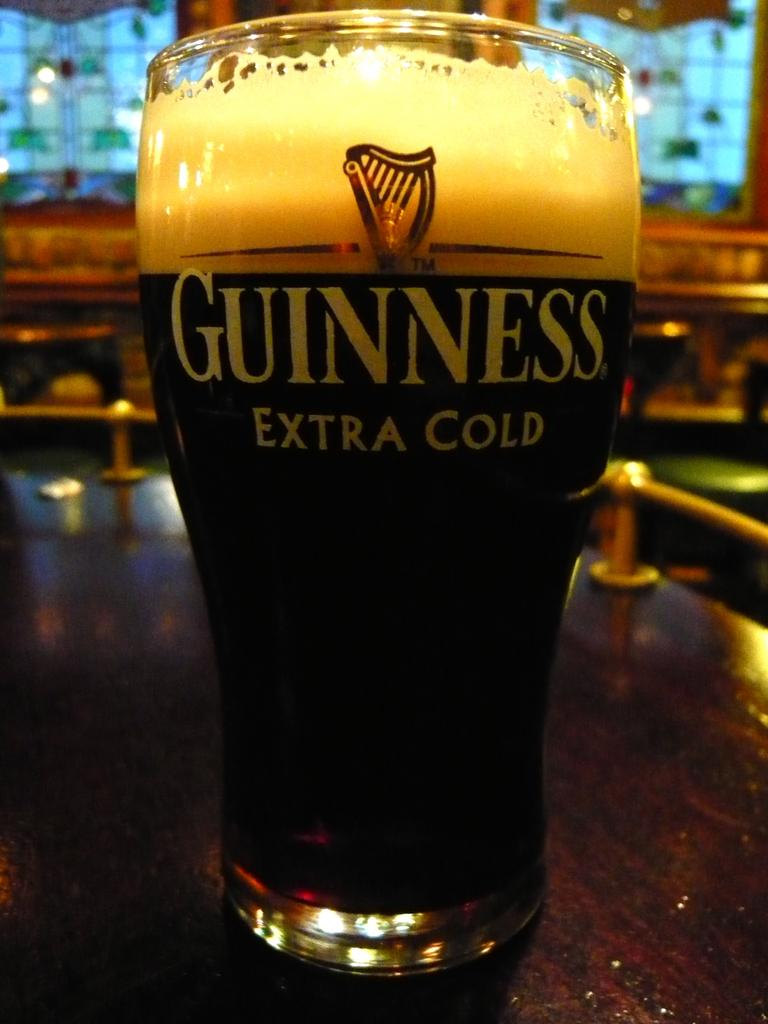<image>
Create a compact narrative representing the image presented. Cold glass of Guinness Extra Cold sitting on a wooden table 